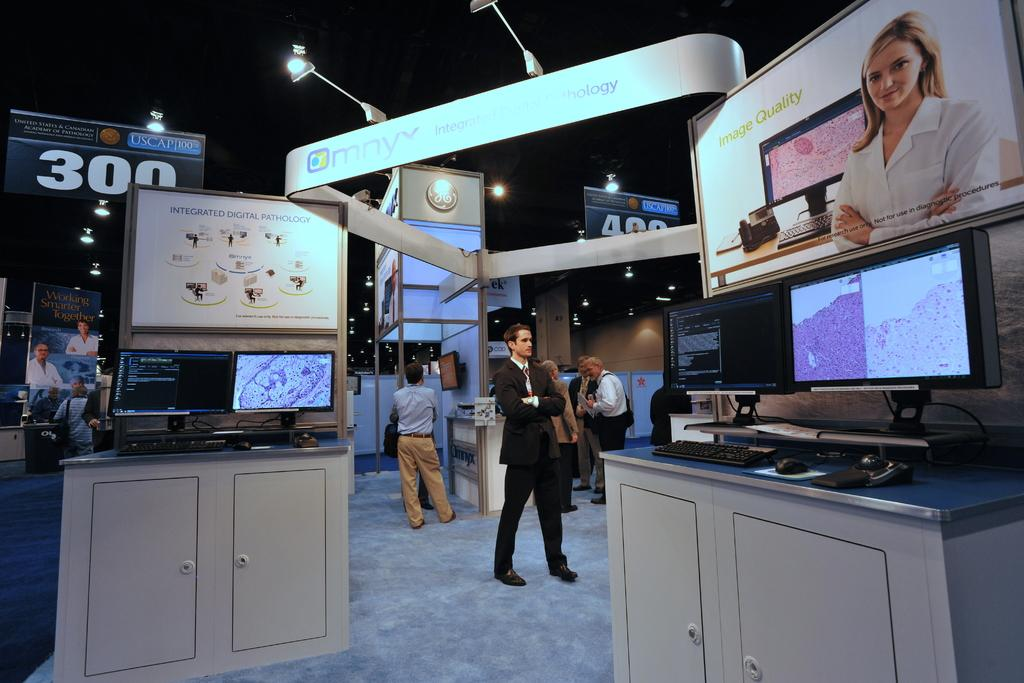<image>
Describe the image concisely. A man in  a suit stands between tv displays about Image Quality and Integrated Digital Pathology in front of a large 300 on the back wall 